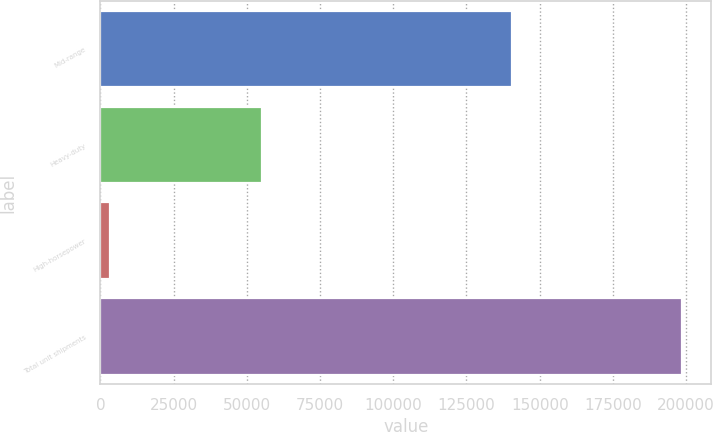Convert chart to OTSL. <chart><loc_0><loc_0><loc_500><loc_500><bar_chart><fcel>Mid-range<fcel>Heavy-duty<fcel>High-horsepower<fcel>Total unit shipments<nl><fcel>140500<fcel>55100<fcel>3100<fcel>198700<nl></chart> 